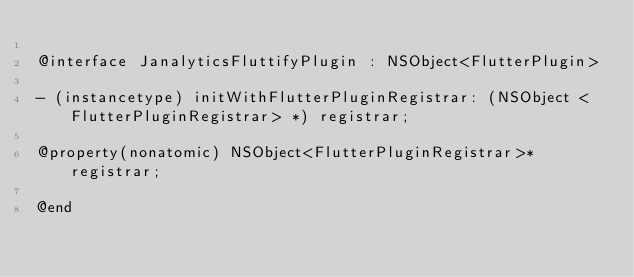<code> <loc_0><loc_0><loc_500><loc_500><_C_>
@interface JanalyticsFluttifyPlugin : NSObject<FlutterPlugin>

- (instancetype) initWithFlutterPluginRegistrar: (NSObject <FlutterPluginRegistrar> *) registrar;

@property(nonatomic) NSObject<FlutterPluginRegistrar>* registrar;

@end
</code> 